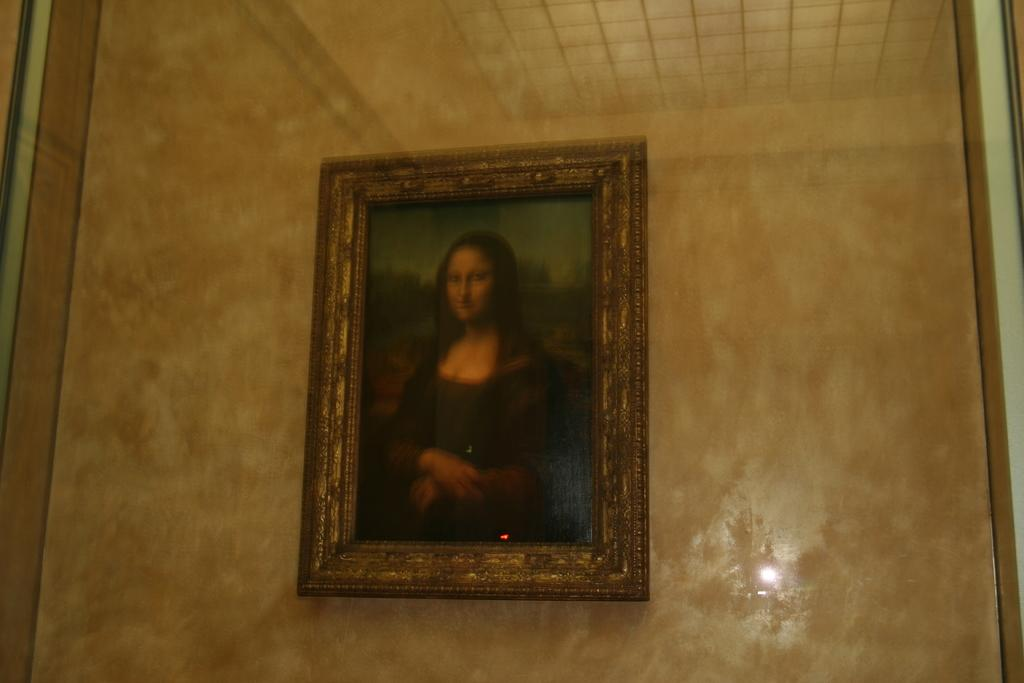What is the color of the surface in the image? The surface in the image is brown colored. What can be seen in the middle of the image? There is a photo frame of a woman in the middle of the image. What type of glove is being used to view the photo frame in the image? There is no glove present in the image, and the photo frame is not being viewed with any object. 